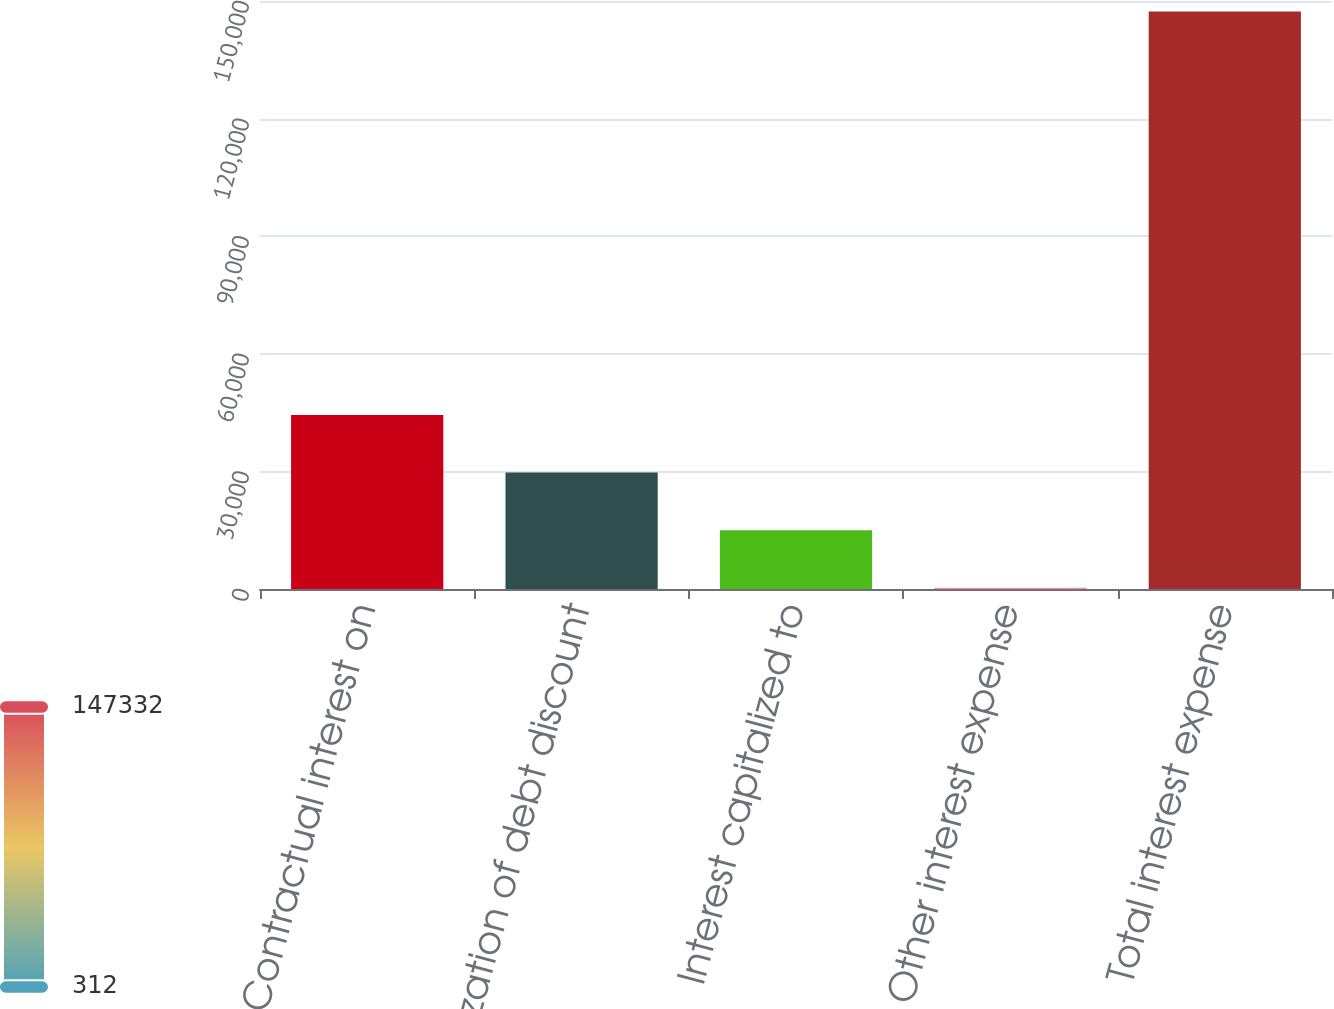Convert chart to OTSL. <chart><loc_0><loc_0><loc_500><loc_500><bar_chart><fcel>Contractual interest on<fcel>Amortization of debt discount<fcel>Interest capitalized to<fcel>Other interest expense<fcel>Total interest expense<nl><fcel>44418<fcel>29716<fcel>15014<fcel>312<fcel>147332<nl></chart> 